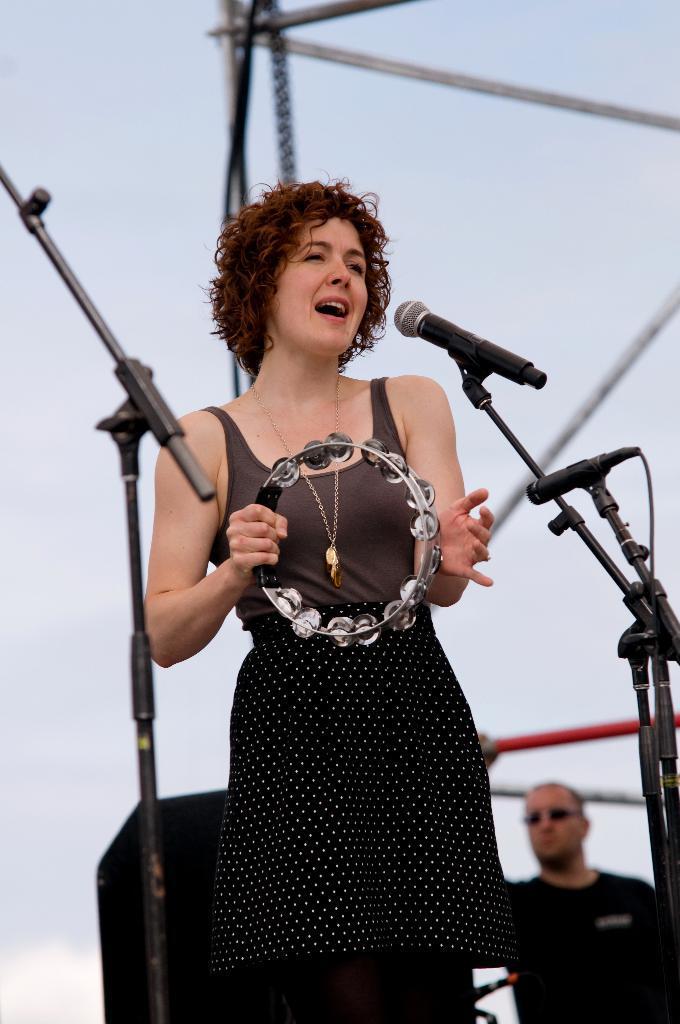How would you summarize this image in a sentence or two? This picture is clicked outside. In the foreground we can see the microphones are attached to the metal stands. In the center there is a woman wearing black color dress, holding a tambourine, standing and seems to be singing. In the background there is a sky and we can see the metal rods, speaker and a person wearing black color t-shirt and seems to be standing. 